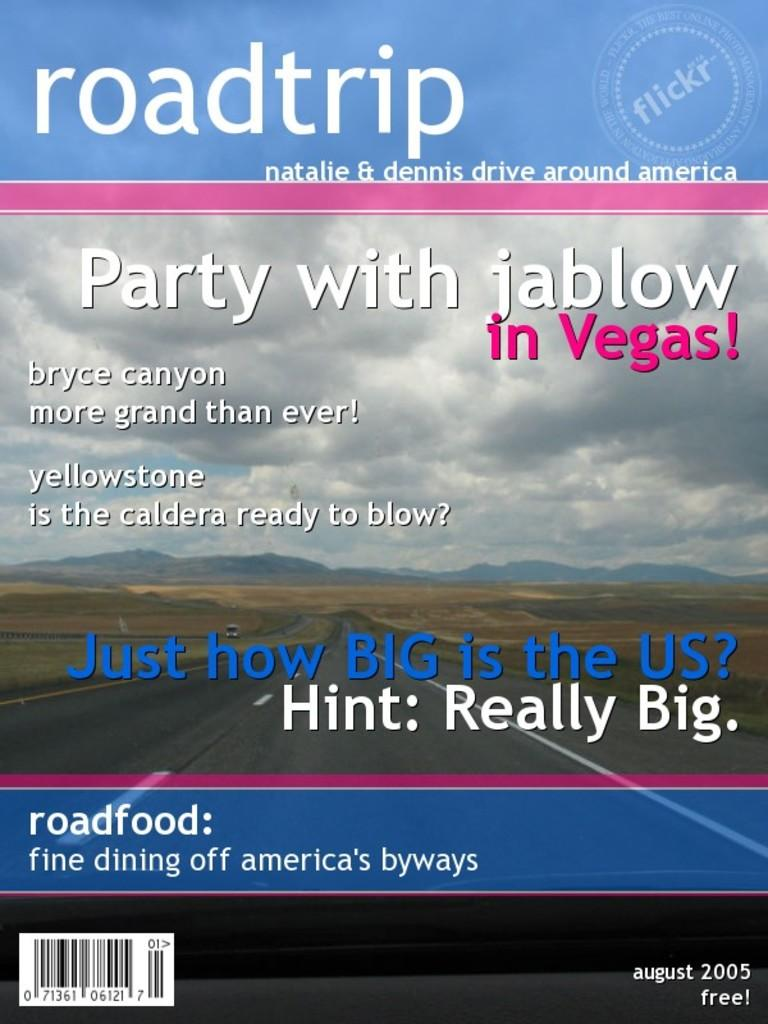What is the main subject of the image? The main subject of the image is the cover of a book. What can be seen in the background of the image? In the background of the image, there are hills, a road, vehicles, and the sky. What is the condition of the sky in the image? The sky is visible in the background of the image, and there are clouds present. Is there any text on the book cover or elsewhere in the image? Yes, there is text at the top and bottom of the image. How many bears can be seen playing in the field in the image? There are no bears or fields present in the image; it features a book cover and a background with hills, a road, vehicles, and the sky. 